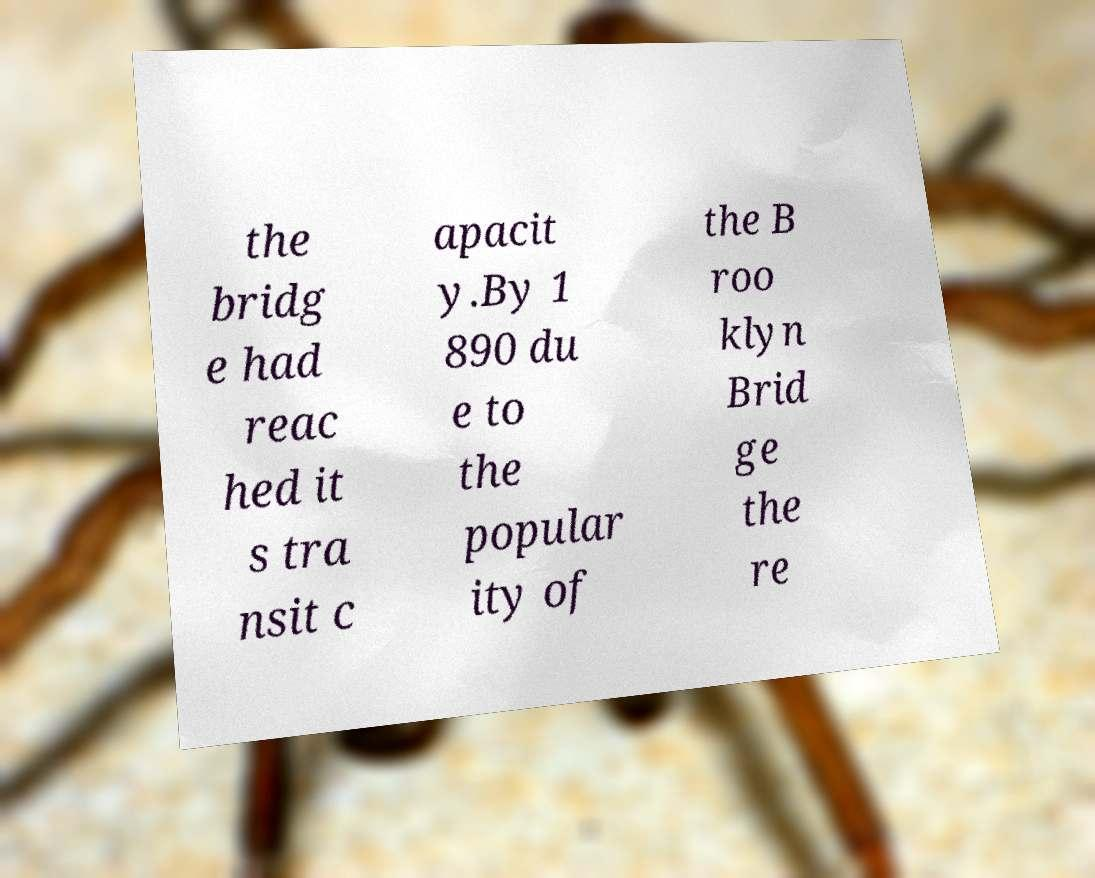There's text embedded in this image that I need extracted. Can you transcribe it verbatim? the bridg e had reac hed it s tra nsit c apacit y.By 1 890 du e to the popular ity of the B roo klyn Brid ge the re 